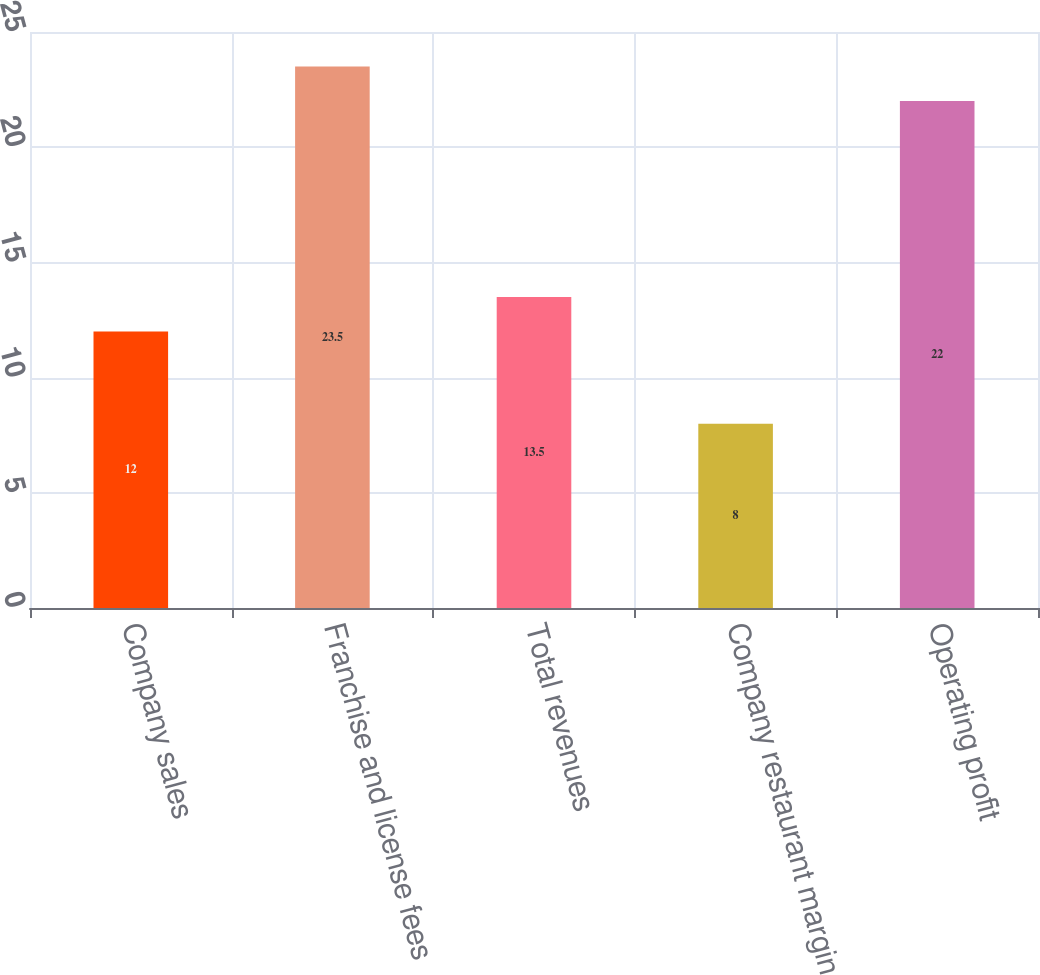<chart> <loc_0><loc_0><loc_500><loc_500><bar_chart><fcel>Company sales<fcel>Franchise and license fees<fcel>Total revenues<fcel>Company restaurant margin<fcel>Operating profit<nl><fcel>12<fcel>23.5<fcel>13.5<fcel>8<fcel>22<nl></chart> 